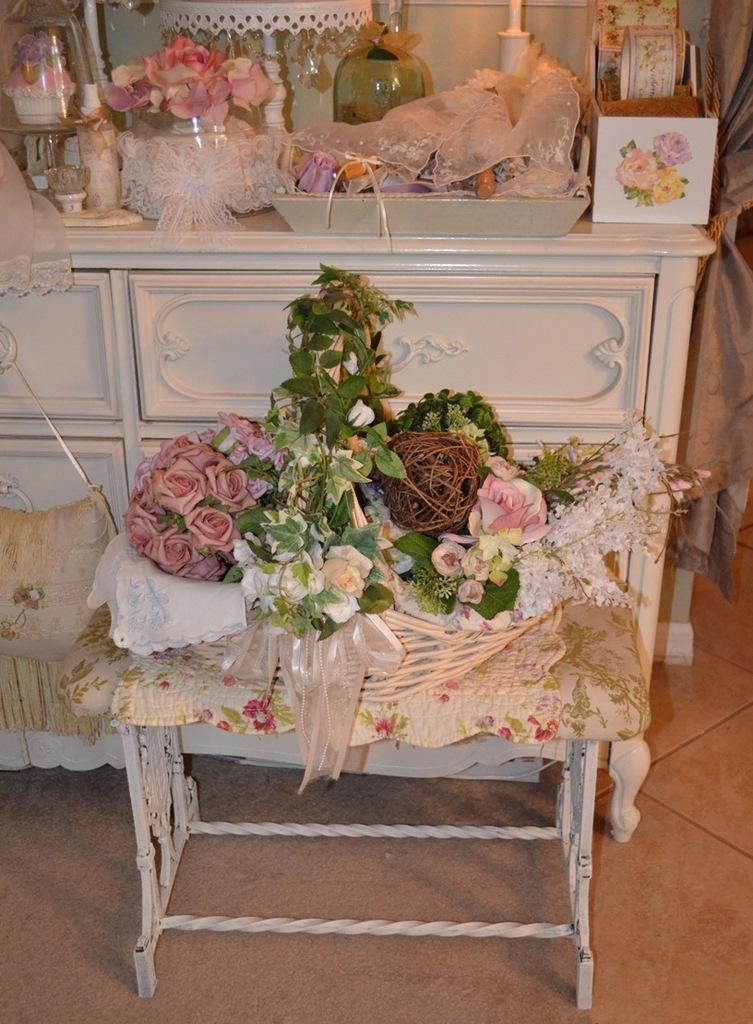Can you describe this image briefly? As we can see in the image there is book, tray, lamp, flowers and on table there are bouquets. 